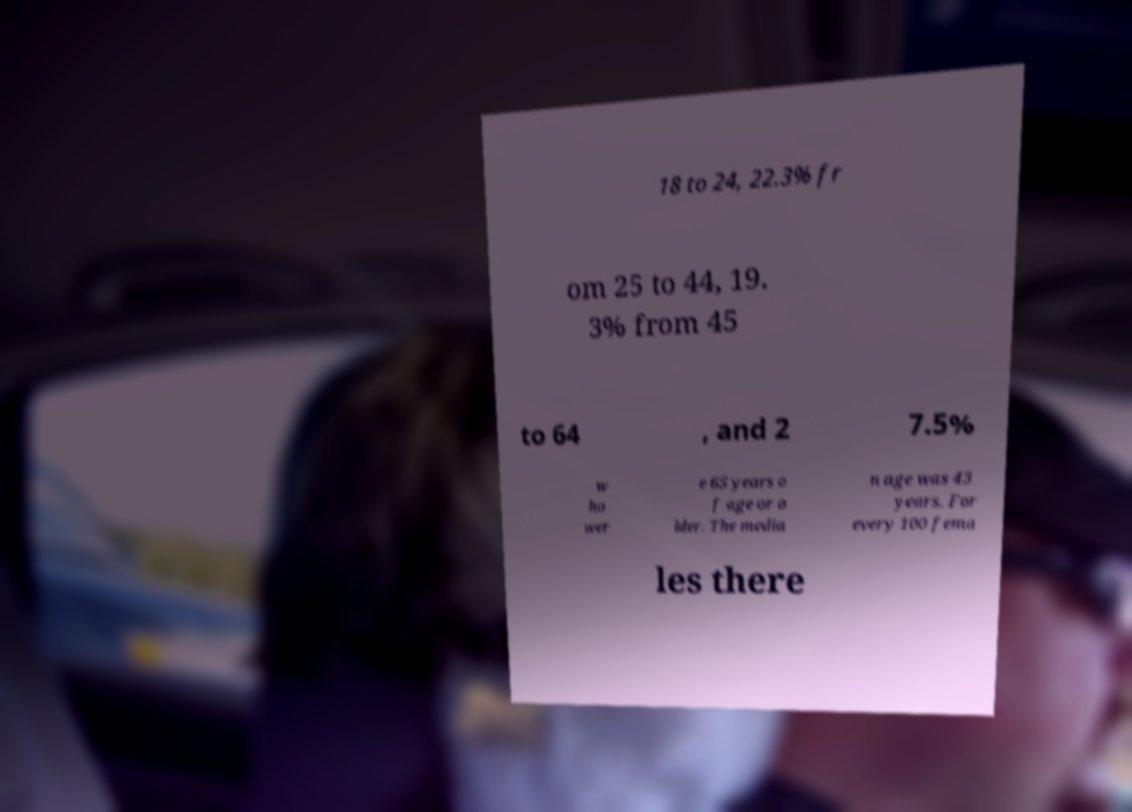What messages or text are displayed in this image? I need them in a readable, typed format. 18 to 24, 22.3% fr om 25 to 44, 19. 3% from 45 to 64 , and 2 7.5% w ho wer e 65 years o f age or o lder. The media n age was 43 years. For every 100 fema les there 